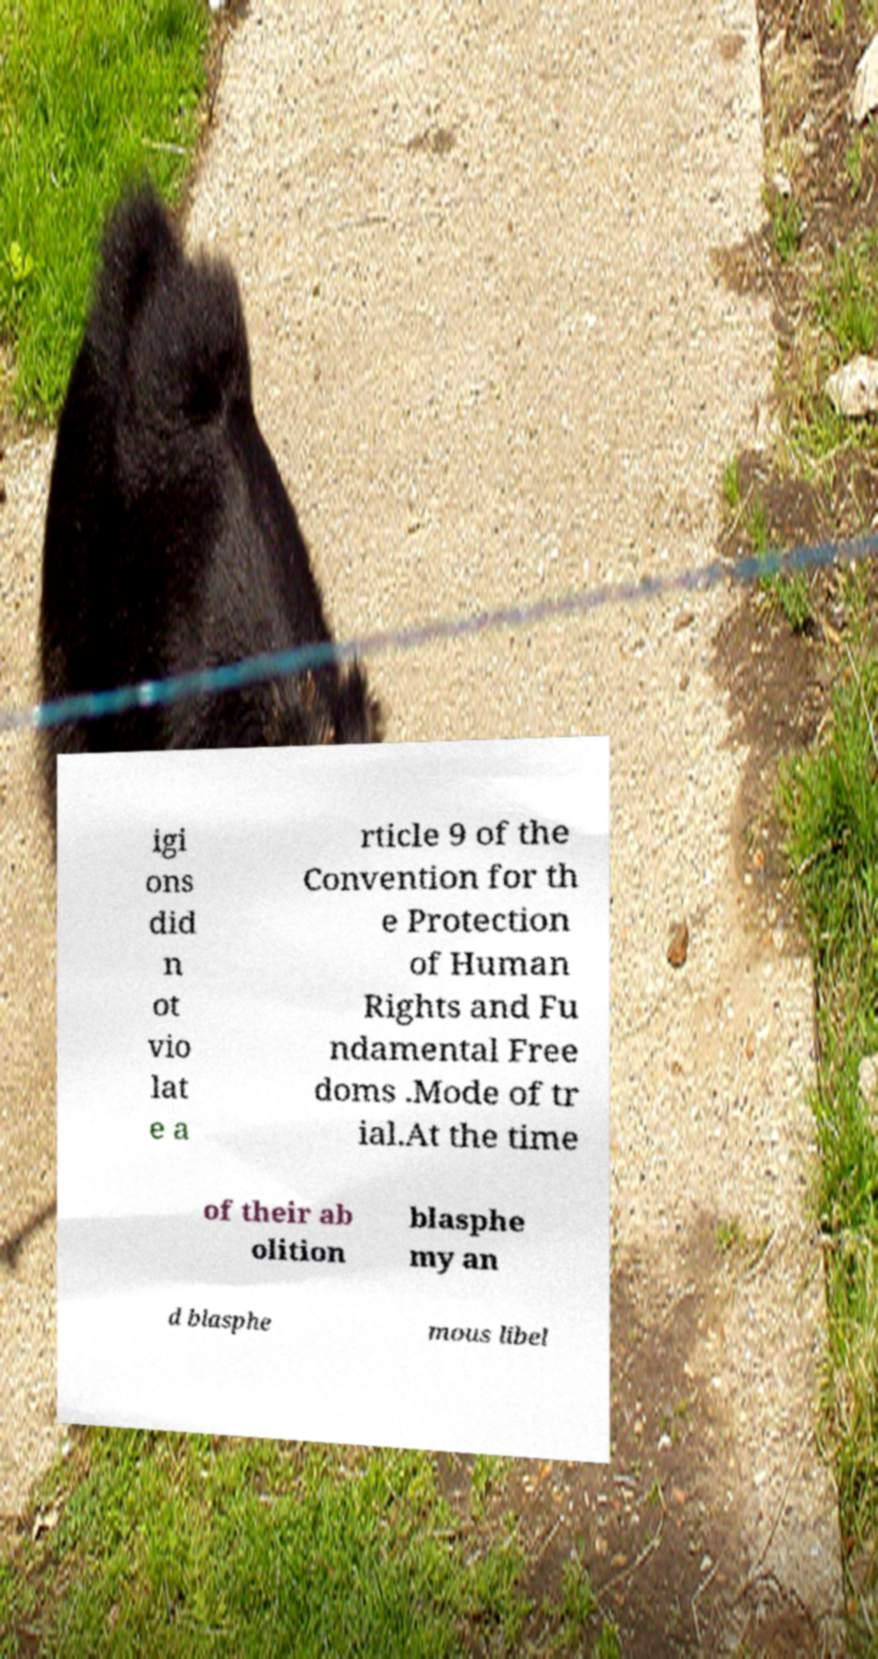I need the written content from this picture converted into text. Can you do that? igi ons did n ot vio lat e a rticle 9 of the Convention for th e Protection of Human Rights and Fu ndamental Free doms .Mode of tr ial.At the time of their ab olition blasphe my an d blasphe mous libel 